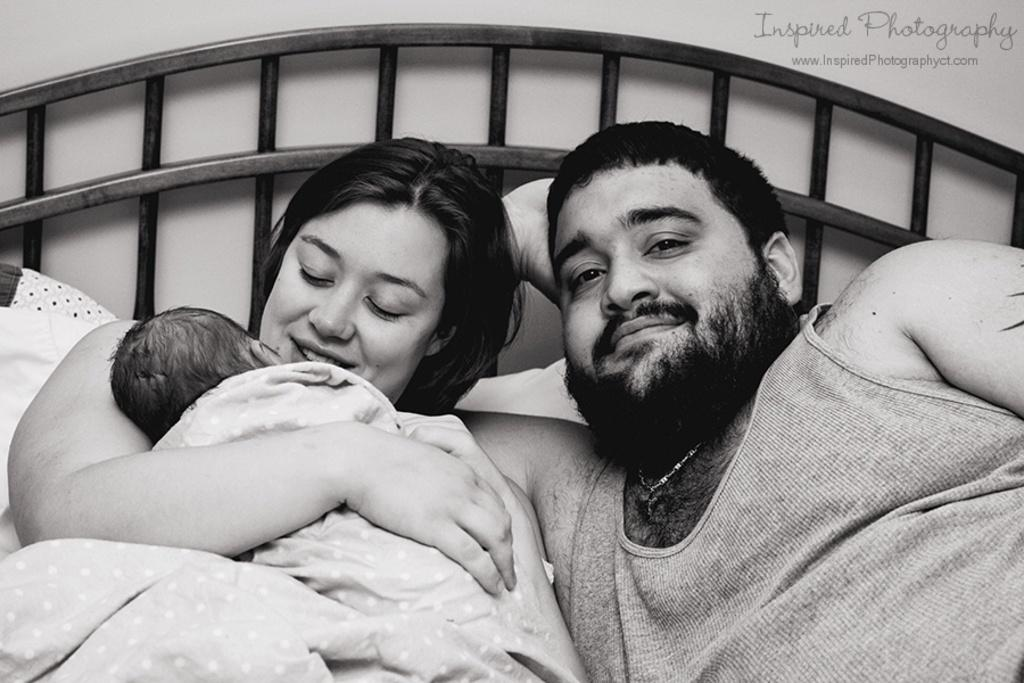What is the color scheme of the image? The image is black and white. How many people are in the image? There is a man, a woman, and a baby in the image. Where are the people located in the image? The people are on a bed in the image. What is present in the top right corner of the image? There is text in the top right corner of the image. What type of silver jewelry is the woman wearing in the image? There is no silver jewelry visible in the image. What is the woman doing to promote peace in the image? There is no indication of promoting peace in the image, as it primarily features a man, a woman, and a baby on a bed. 